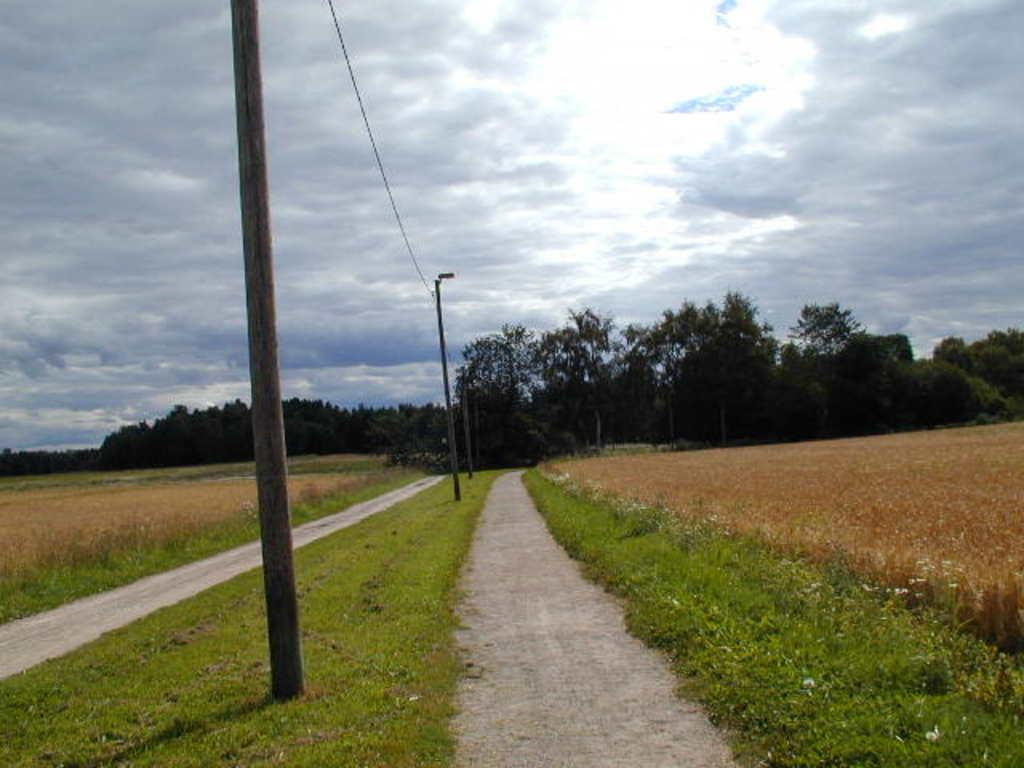What structures are located on the left side of the image? There are poles on the left side of the image. What type of terrain is visible on both sides of the image? There is grassland on both the left and right sides of the image. What can be seen in the background of the image? There are trees in the background of the image. What flavor of robin can be seen perched on the poles in the image? There are no birds, specifically robins, present in the image. What subject is being taught in the image? There is no teaching or educational activity depicted in the image. 